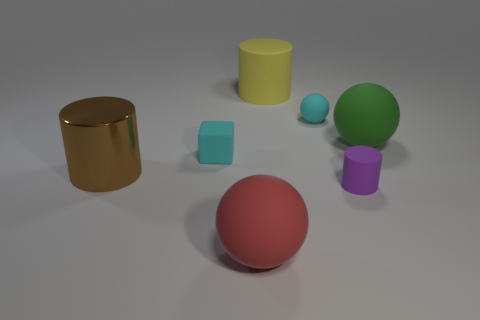What size is the thing that is the same color as the small rubber block?
Your response must be concise. Small. There is a cylinder that is both to the right of the red thing and behind the purple cylinder; how big is it?
Provide a succinct answer. Large. What is the material of the sphere that is the same color as the tiny cube?
Provide a succinct answer. Rubber. What is the shape of the thing that is behind the brown metallic cylinder and to the left of the red matte sphere?
Give a very brief answer. Cube. Are there any other things that have the same size as the purple object?
Your answer should be compact. Yes. Do the thing that is right of the purple thing and the tiny cyan matte thing that is to the left of the red rubber sphere have the same shape?
Offer a terse response. No. How many spheres are either small blue metal things or big brown shiny objects?
Provide a short and direct response. 0. Are there fewer red rubber balls left of the big red object than large yellow matte objects?
Your answer should be very brief. Yes. How many other things are there of the same material as the block?
Your response must be concise. 5. Is the green sphere the same size as the yellow rubber thing?
Offer a terse response. Yes. 